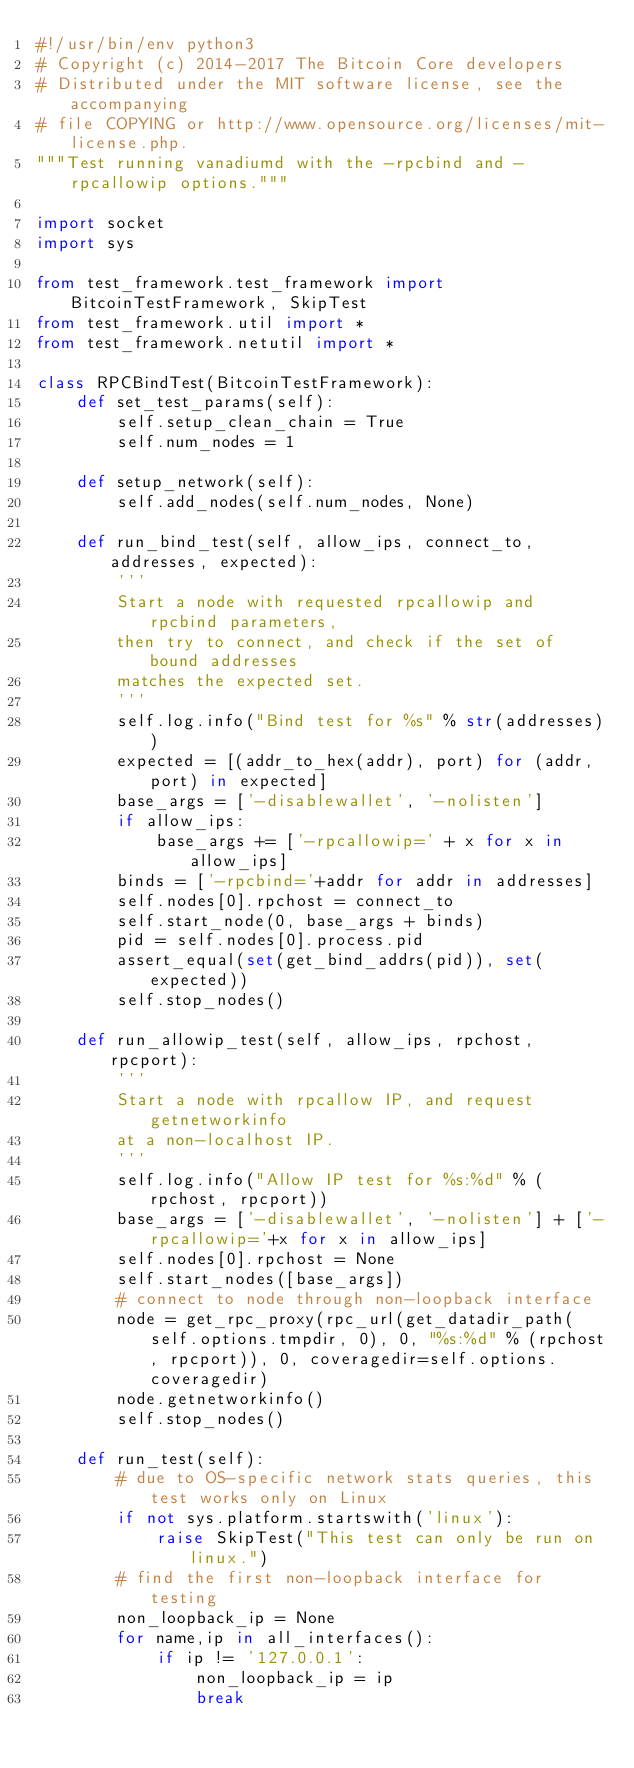<code> <loc_0><loc_0><loc_500><loc_500><_Python_>#!/usr/bin/env python3
# Copyright (c) 2014-2017 The Bitcoin Core developers
# Distributed under the MIT software license, see the accompanying
# file COPYING or http://www.opensource.org/licenses/mit-license.php.
"""Test running vanadiumd with the -rpcbind and -rpcallowip options."""

import socket
import sys

from test_framework.test_framework import BitcoinTestFramework, SkipTest
from test_framework.util import *
from test_framework.netutil import *

class RPCBindTest(BitcoinTestFramework):
    def set_test_params(self):
        self.setup_clean_chain = True
        self.num_nodes = 1

    def setup_network(self):
        self.add_nodes(self.num_nodes, None)

    def run_bind_test(self, allow_ips, connect_to, addresses, expected):
        '''
        Start a node with requested rpcallowip and rpcbind parameters,
        then try to connect, and check if the set of bound addresses
        matches the expected set.
        '''
        self.log.info("Bind test for %s" % str(addresses))
        expected = [(addr_to_hex(addr), port) for (addr, port) in expected]
        base_args = ['-disablewallet', '-nolisten']
        if allow_ips:
            base_args += ['-rpcallowip=' + x for x in allow_ips]
        binds = ['-rpcbind='+addr for addr in addresses]
        self.nodes[0].rpchost = connect_to
        self.start_node(0, base_args + binds)
        pid = self.nodes[0].process.pid
        assert_equal(set(get_bind_addrs(pid)), set(expected))
        self.stop_nodes()

    def run_allowip_test(self, allow_ips, rpchost, rpcport):
        '''
        Start a node with rpcallow IP, and request getnetworkinfo
        at a non-localhost IP.
        '''
        self.log.info("Allow IP test for %s:%d" % (rpchost, rpcport))
        base_args = ['-disablewallet', '-nolisten'] + ['-rpcallowip='+x for x in allow_ips]
        self.nodes[0].rpchost = None
        self.start_nodes([base_args])
        # connect to node through non-loopback interface
        node = get_rpc_proxy(rpc_url(get_datadir_path(self.options.tmpdir, 0), 0, "%s:%d" % (rpchost, rpcport)), 0, coveragedir=self.options.coveragedir)
        node.getnetworkinfo()
        self.stop_nodes()

    def run_test(self):
        # due to OS-specific network stats queries, this test works only on Linux
        if not sys.platform.startswith('linux'):
            raise SkipTest("This test can only be run on linux.")
        # find the first non-loopback interface for testing
        non_loopback_ip = None
        for name,ip in all_interfaces():
            if ip != '127.0.0.1':
                non_loopback_ip = ip
                break</code> 